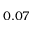<formula> <loc_0><loc_0><loc_500><loc_500>0 . 0 7</formula> 